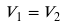Convert formula to latex. <formula><loc_0><loc_0><loc_500><loc_500>V _ { 1 } = V _ { 2 }</formula> 